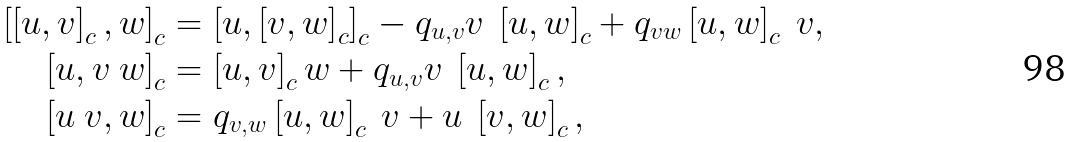<formula> <loc_0><loc_0><loc_500><loc_500>\left [ \left [ u , v \right ] _ { c } , w \right ] _ { c } & = \left [ u , \left [ v , w \right ] _ { c } \right ] _ { c } - q _ { u , v } v \ \left [ u , w \right ] _ { c } + q _ { v w } \left [ u , w \right ] _ { c } \ v , \\ \left [ u , v \ w \right ] _ { c } & = \left [ u , v \right ] _ { c } w + q _ { u , v } v \ \left [ u , w \right ] _ { c } , \\ \left [ u \ v , w \right ] _ { c } & = q _ { v , w } \left [ u , w \right ] _ { c } \ v + u \ \left [ v , w \right ] _ { c } ,</formula> 